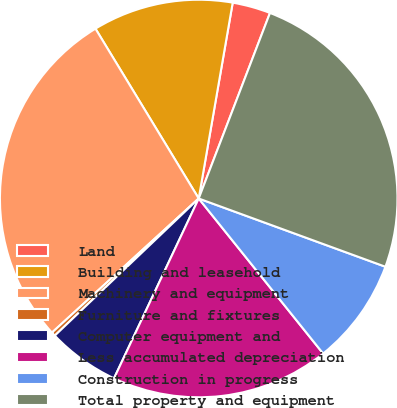Convert chart. <chart><loc_0><loc_0><loc_500><loc_500><pie_chart><fcel>Land<fcel>Building and leasehold<fcel>Machinery and equipment<fcel>Furniture and fixtures<fcel>Computer equipment and<fcel>Less accumulated depreciation<fcel>Construction in progress<fcel>Total property and equipment<nl><fcel>3.1%<fcel>11.43%<fcel>28.09%<fcel>0.33%<fcel>5.88%<fcel>17.77%<fcel>8.66%<fcel>24.74%<nl></chart> 